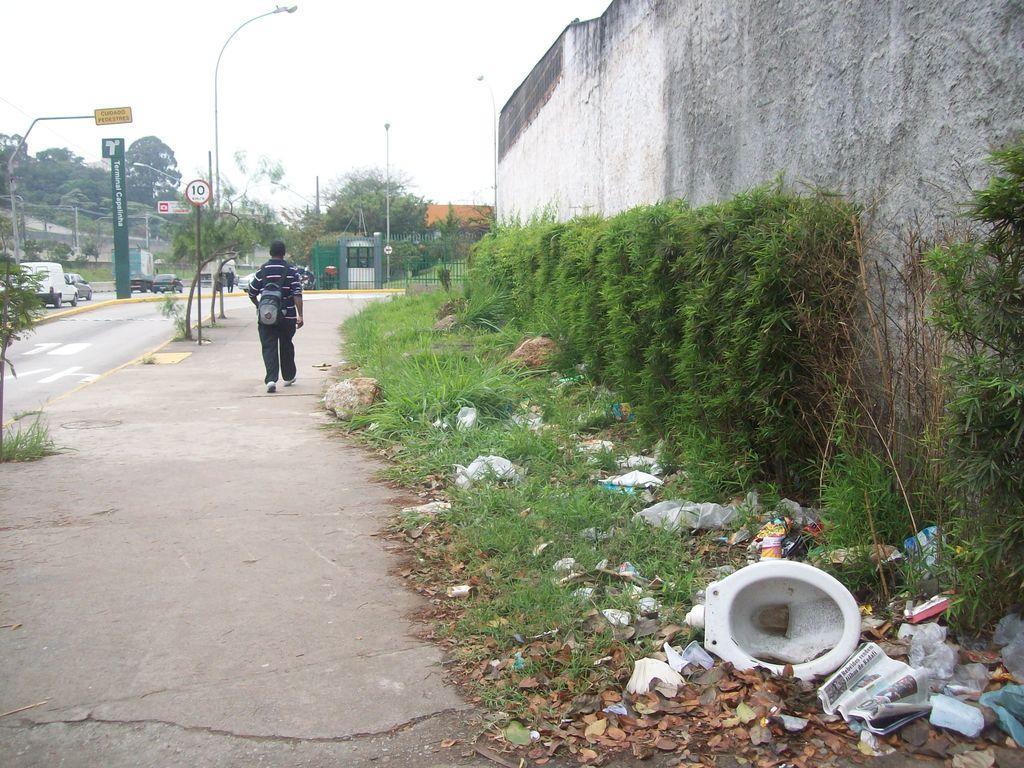Can you describe this image briefly? In this picture I can observe a man walking in this path. On the right side I can observe some plants and garbage on the ground. In the background there are trees and sky. 